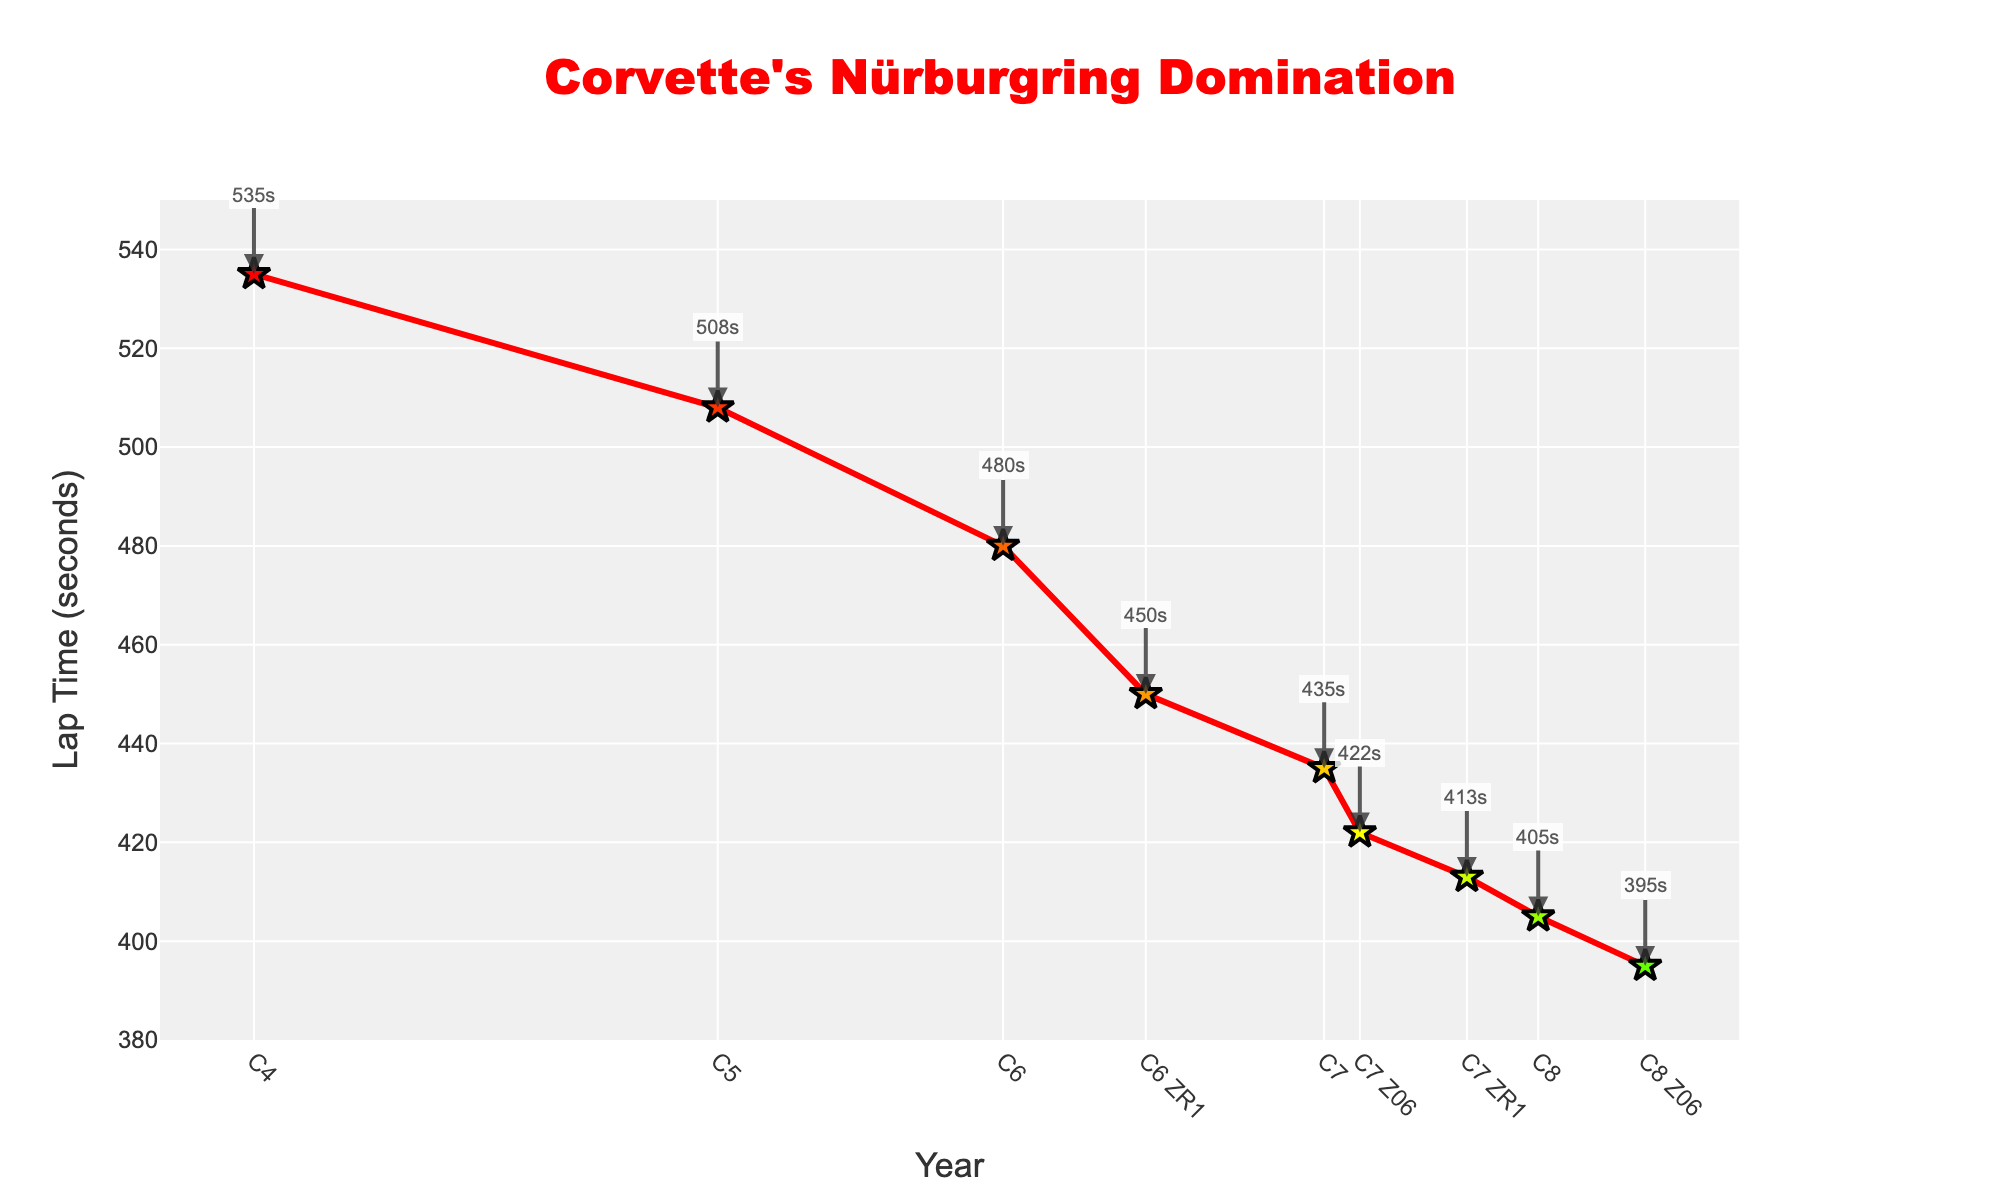What is the lap time for the C6 generation? Look for the data point associated with the C6 generation, which corresponds to the year 2005. The lap time for this point is labeled as "480s".
Answer: 480s Which Corvette generation achieved the fastest Nürburgring lap time? Compare the lap times of all the generations in the figure to find the one with the smallest lap time. The C8 Z06 generation in 2023 has the fastest lap time of "395s".
Answer: C8 Z06 How much did the lap time improve from the C4 to the C8 generation? Subtract the lap time of the C8 generation from the lap time of the C4 generation. The lap times are 535s for the C4 (1984) and 405s for the C8 (2020). The improvement is 535s - 405s = 130s.
Answer: 130s What is the average lap time of the Corvette Z models (C6 ZR1, C7 Z06, C7 ZR1, C8 Z06)? Find the lap times of the Z models: 450s (C6 ZR1), 422s (C7 Z06), 413s (C7 ZR1), and 395s (C8 Z06). Calculate the average: (450 + 422 + 413 + 395) / 4 = 420s.
Answer: 420s Between which two consecutive generations was the biggest improvement in lap times observed? Calculate the improvement between each consecutive generation and compare them. The improvements are: C4 (535s) to C5 (508s) is 27s, C5 (508s) to C6 (480s) is 28s, C6 (480s) to C6 ZR1 (450s) is 30s, C6 ZR1 (450s) to C7 (435s) is 15s, C7 (435s) to C7 Z06 (422s) is 13s, C7 Z06 (422s) to C7 ZR1 (413s) is 9s, C7 ZR1 (413s) to C8 (405s) is 8s, and C8 (405s) to C8 Z06 (395s) is 10s. The biggest improvement is between C6 (2005) and C6 ZR1 (2009) with a 30s reduction.
Answer: C6 to C6 ZR1 Which year had the lap time closest to 420 seconds? Find the lap time values and check which is closest to 420 seconds. The closest lap time is from the C7 Z06 in 2015 with a lap time of 422 seconds.
Answer: 2015 How many years did it take for the lap time to drop below 450 seconds? Identify when lap times fell below 450 seconds and count the years from the first data point (1984) to when this milestone was reached (C6 ZR1 in 2009). The span is 2009 - 1984 = 25 years.
Answer: 25 years 